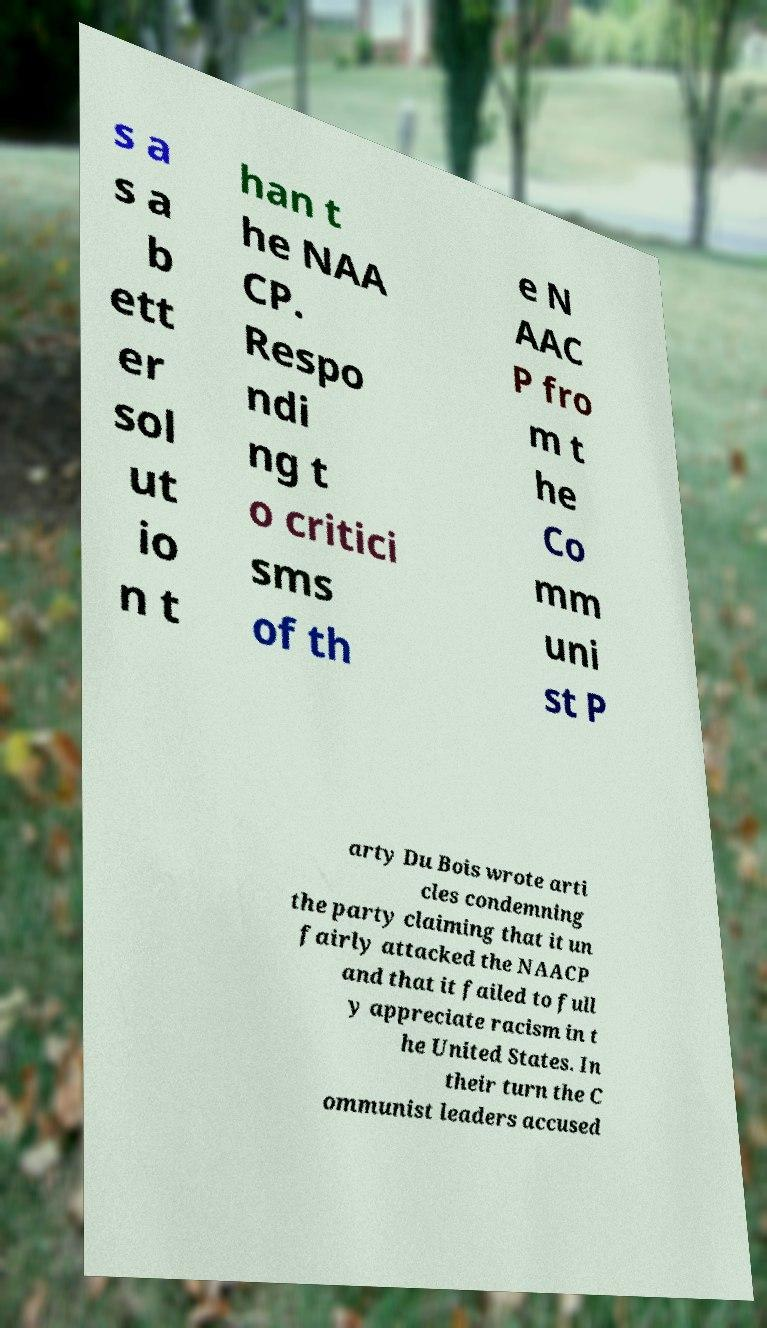Can you accurately transcribe the text from the provided image for me? s a s a b ett er sol ut io n t han t he NAA CP. Respo ndi ng t o critici sms of th e N AAC P fro m t he Co mm uni st P arty Du Bois wrote arti cles condemning the party claiming that it un fairly attacked the NAACP and that it failed to full y appreciate racism in t he United States. In their turn the C ommunist leaders accused 